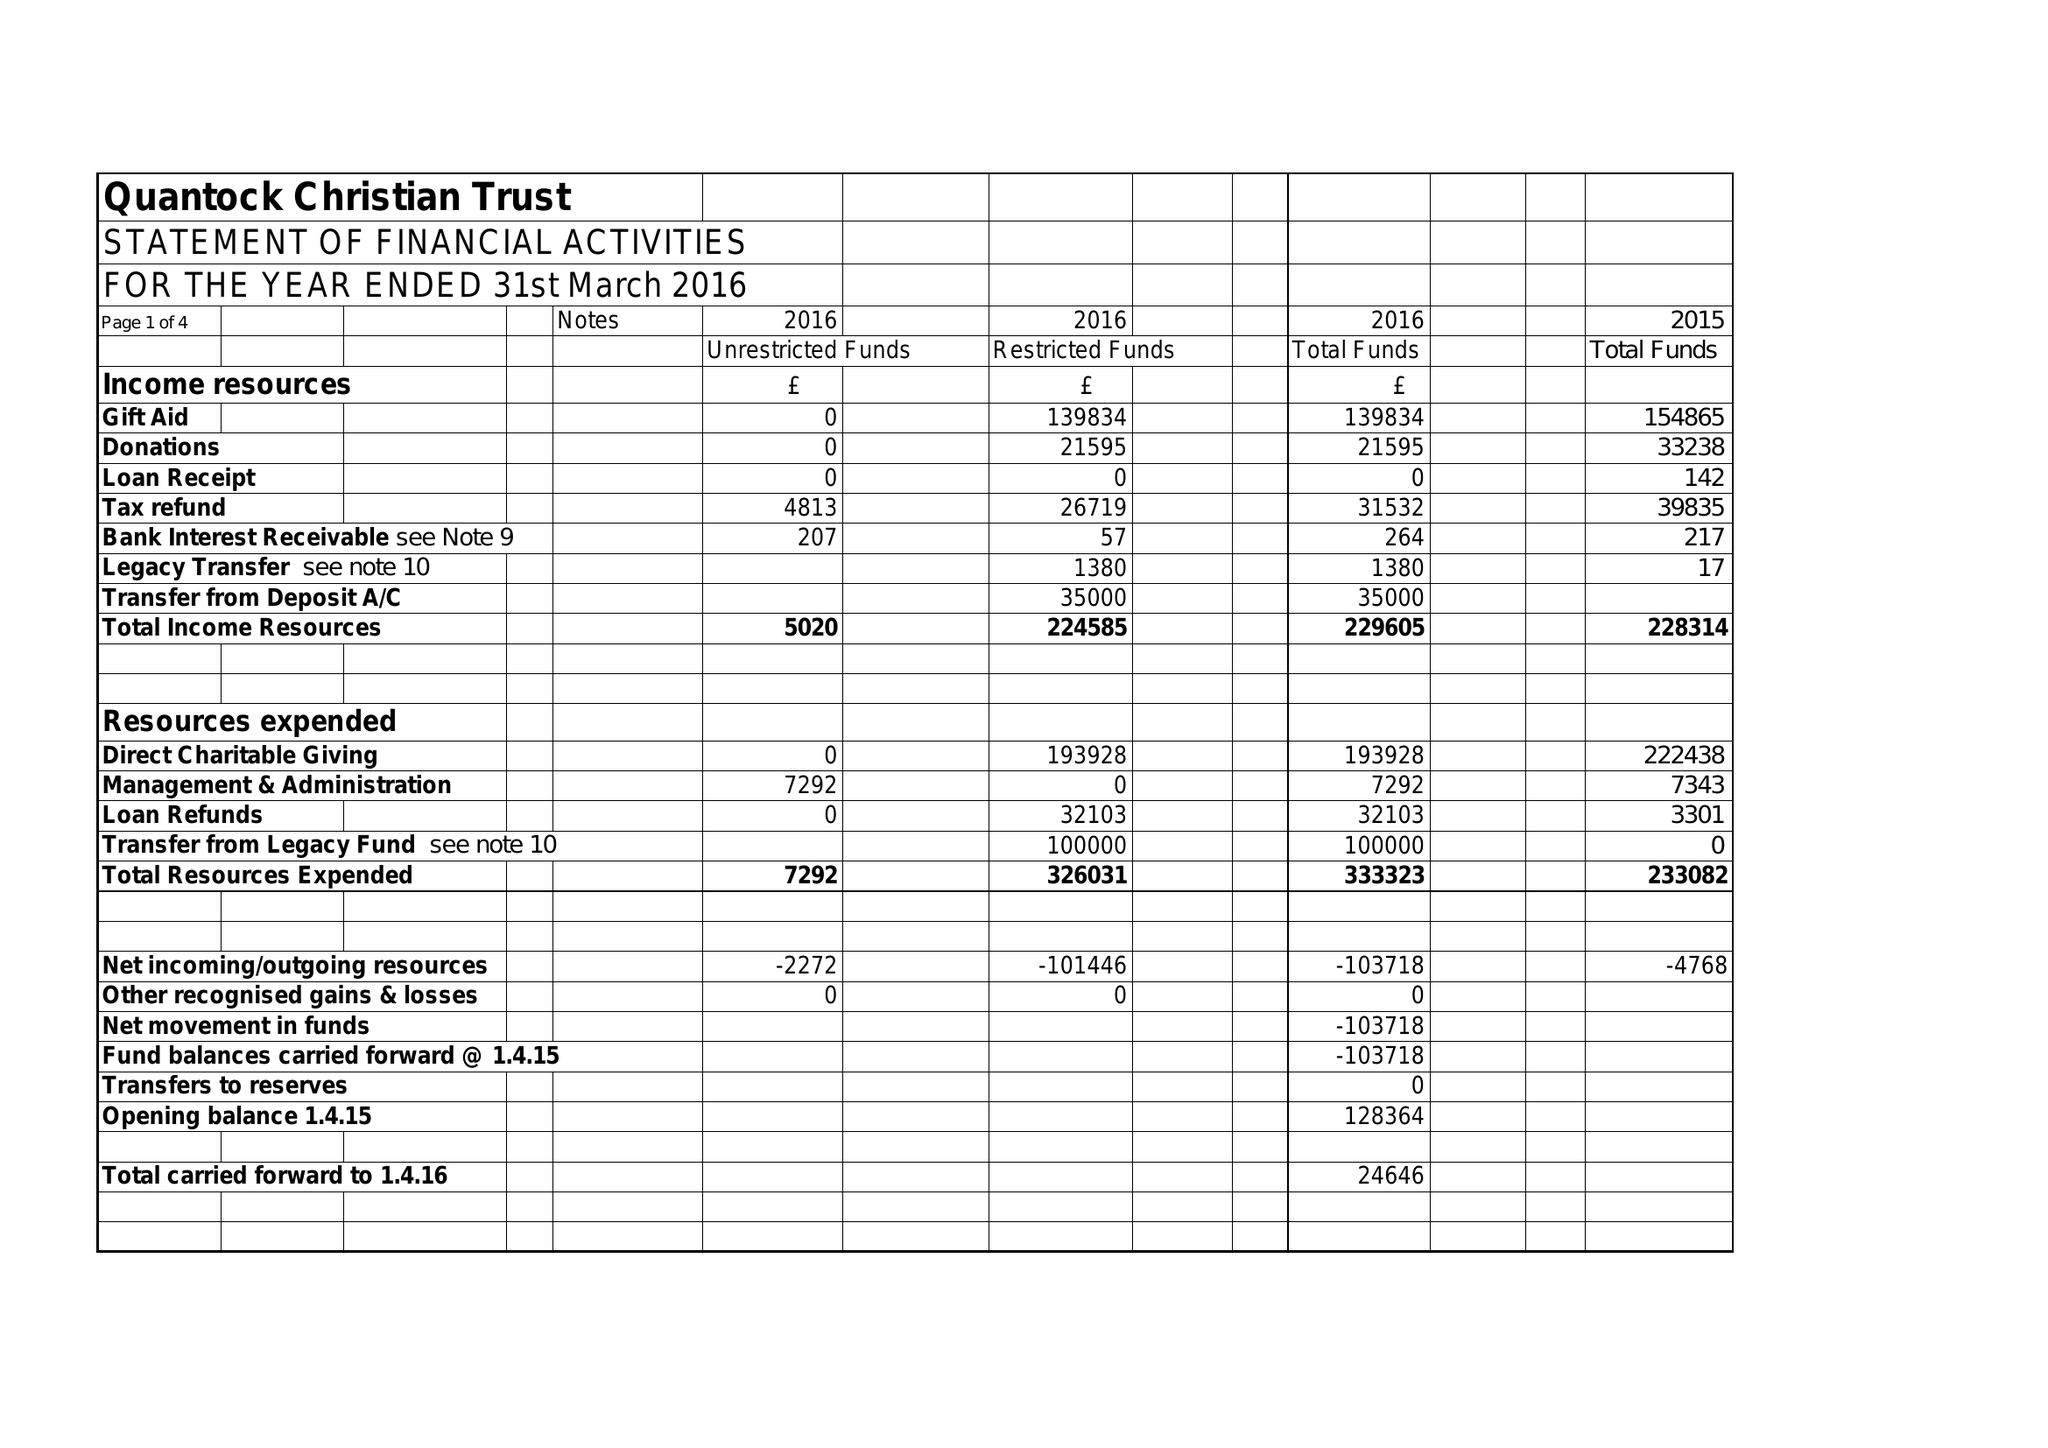What is the value for the report_date?
Answer the question using a single word or phrase. 2016-03-31 